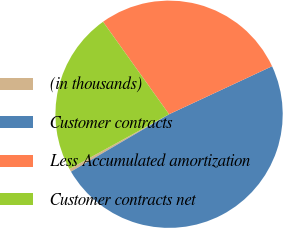<chart> <loc_0><loc_0><loc_500><loc_500><pie_chart><fcel>(in thousands)<fcel>Customer contracts<fcel>Less Accumulated amortization<fcel>Customer contracts net<nl><fcel>0.43%<fcel>48.51%<fcel>27.93%<fcel>23.13%<nl></chart> 